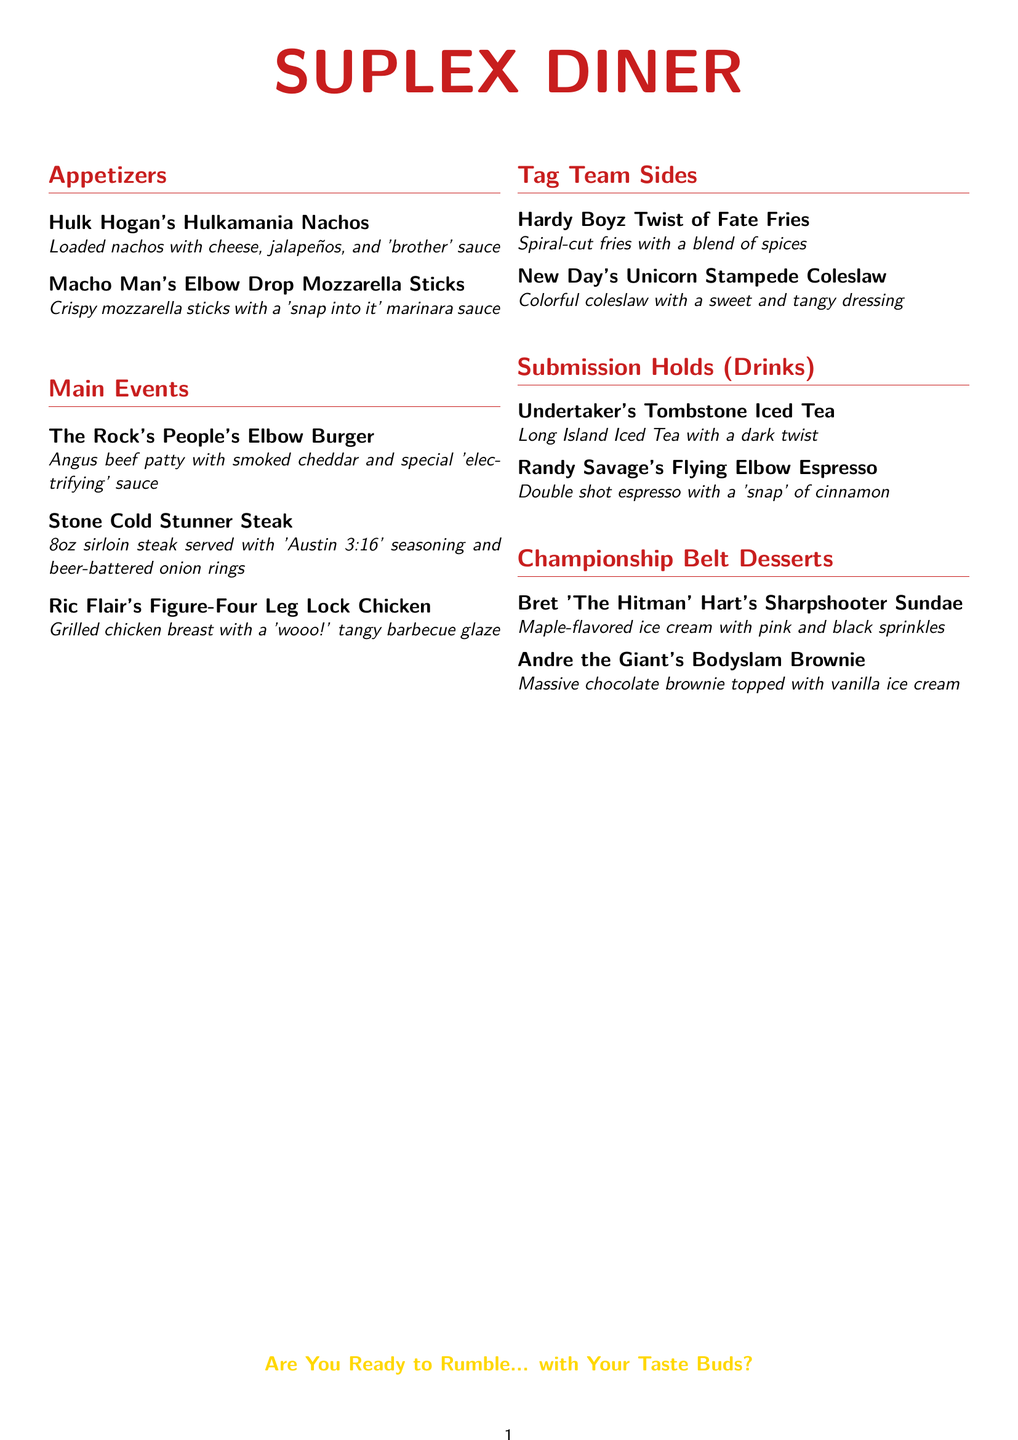What are the appetizers listed? The appetizers listed include Hulk Hogan's Hulkamania Nachos and Macho Man's Elbow Drop Mozzarella Sticks.
Answer: Hulk Hogan's Hulkamania Nachos, Macho Man's Elbow Drop Mozzarella Sticks What type of steak is served in the Stone Cold Stunner dish? The Stone Cold Stunner dish features an 8oz sirloin steak.
Answer: 8oz sirloin steak What is the key ingredient in Ric Flair's Figure-Four Leg Lock Chicken? The key ingredient in the Ric Flair's Figure-Four Leg Lock Chicken is grilled chicken breast.
Answer: Grilled chicken breast How many desserts are offered in the menu? The dessert section lists two items, which are Bret 'The Hitman' Hart's Sharpshooter Sundae and Andre the Giant's Bodyslam Brownie.
Answer: 2 What is the base flavor of the sundae named after Bret 'The Hitman' Hart? The base flavor of Bret 'The Hitman' Hart's Sharpshooter Sundae is maple-flavored ice cream.
Answer: Maple-flavored ice cream What type of sauce comes with the Hulkamania Nachos? The Hulkamania Nachos are served with 'brother' sauce.
Answer: 'Brother' sauce Which drink contains a double shot of espresso? Randy Savage's Flying Elbow Espresso is the drink that contains a double shot of espresso.
Answer: Randy Savage's Flying Elbow Espresso What colors are in New Day's Unicorn Stampede Coleslaw? New Day's Unicorn Stampede Coleslaw has colorful ingredients with a sweet and tangy dressing.
Answer: Colorful 